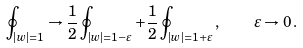Convert formula to latex. <formula><loc_0><loc_0><loc_500><loc_500>\oint \nolimits _ { | w | = 1 } \to \frac { 1 } { 2 } \oint \nolimits _ { | w | = 1 - \varepsilon } + \frac { 1 } { 2 } \oint \nolimits _ { | w | = 1 + \varepsilon } \, , \quad \varepsilon \to 0 \, .</formula> 